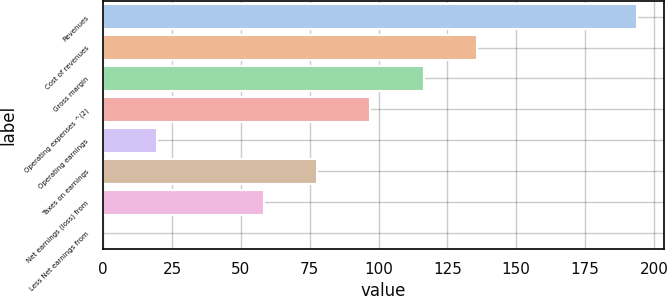Convert chart to OTSL. <chart><loc_0><loc_0><loc_500><loc_500><bar_chart><fcel>Revenues<fcel>Cost of revenues<fcel>Gross margin<fcel>Operating expenses ^(2)<fcel>Operating earnings<fcel>Taxes on earnings<fcel>Net earnings (loss) from<fcel>Less Net earnings from<nl><fcel>194<fcel>135.83<fcel>116.44<fcel>97.05<fcel>19.49<fcel>77.66<fcel>58.27<fcel>0.1<nl></chart> 